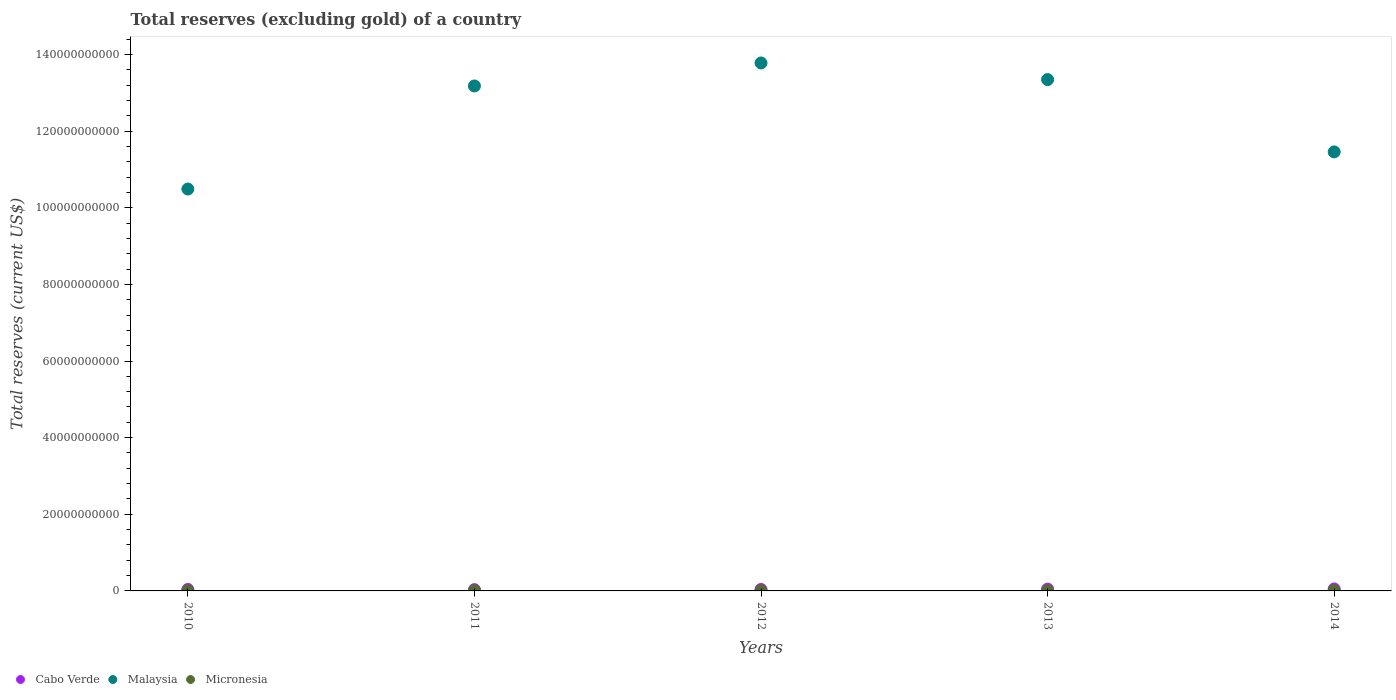How many different coloured dotlines are there?
Your answer should be very brief. 3. Is the number of dotlines equal to the number of legend labels?
Offer a terse response. Yes. What is the total reserves (excluding gold) in Cabo Verde in 2014?
Give a very brief answer. 5.11e+08. Across all years, what is the maximum total reserves (excluding gold) in Cabo Verde?
Ensure brevity in your answer.  5.11e+08. Across all years, what is the minimum total reserves (excluding gold) in Cabo Verde?
Provide a succinct answer. 3.39e+08. In which year was the total reserves (excluding gold) in Cabo Verde maximum?
Keep it short and to the point. 2014. In which year was the total reserves (excluding gold) in Cabo Verde minimum?
Offer a very short reply. 2011. What is the total total reserves (excluding gold) in Micronesia in the graph?
Give a very brief answer. 4.06e+08. What is the difference between the total reserves (excluding gold) in Malaysia in 2010 and that in 2014?
Give a very brief answer. -9.69e+09. What is the difference between the total reserves (excluding gold) in Micronesia in 2011 and the total reserves (excluding gold) in Cabo Verde in 2010?
Keep it short and to the point. -3.07e+08. What is the average total reserves (excluding gold) in Micronesia per year?
Keep it short and to the point. 8.12e+07. In the year 2010, what is the difference between the total reserves (excluding gold) in Micronesia and total reserves (excluding gold) in Malaysia?
Make the answer very short. -1.05e+11. In how many years, is the total reserves (excluding gold) in Cabo Verde greater than 104000000000 US$?
Offer a terse response. 0. What is the ratio of the total reserves (excluding gold) in Cabo Verde in 2011 to that in 2012?
Ensure brevity in your answer.  0.9. Is the total reserves (excluding gold) in Malaysia in 2011 less than that in 2012?
Keep it short and to the point. Yes. Is the difference between the total reserves (excluding gold) in Micronesia in 2012 and 2013 greater than the difference between the total reserves (excluding gold) in Malaysia in 2012 and 2013?
Keep it short and to the point. No. What is the difference between the highest and the second highest total reserves (excluding gold) in Cabo Verde?
Your answer should be compact. 3.56e+07. What is the difference between the highest and the lowest total reserves (excluding gold) in Cabo Verde?
Offer a very short reply. 1.72e+08. Is the sum of the total reserves (excluding gold) in Cabo Verde in 2010 and 2012 greater than the maximum total reserves (excluding gold) in Micronesia across all years?
Offer a very short reply. Yes. Does the total reserves (excluding gold) in Micronesia monotonically increase over the years?
Ensure brevity in your answer.  Yes. Is the total reserves (excluding gold) in Malaysia strictly greater than the total reserves (excluding gold) in Cabo Verde over the years?
Provide a succinct answer. Yes. Is the total reserves (excluding gold) in Cabo Verde strictly less than the total reserves (excluding gold) in Micronesia over the years?
Provide a succinct answer. No. How many dotlines are there?
Offer a terse response. 3. What is the difference between two consecutive major ticks on the Y-axis?
Offer a terse response. 2.00e+1. Are the values on the major ticks of Y-axis written in scientific E-notation?
Your response must be concise. No. Does the graph contain any zero values?
Make the answer very short. No. Where does the legend appear in the graph?
Your response must be concise. Bottom left. How are the legend labels stacked?
Give a very brief answer. Horizontal. What is the title of the graph?
Give a very brief answer. Total reserves (excluding gold) of a country. What is the label or title of the Y-axis?
Provide a succinct answer. Total reserves (current US$). What is the Total reserves (current US$) in Cabo Verde in 2010?
Give a very brief answer. 3.82e+08. What is the Total reserves (current US$) of Malaysia in 2010?
Ensure brevity in your answer.  1.05e+11. What is the Total reserves (current US$) of Micronesia in 2010?
Offer a very short reply. 5.58e+07. What is the Total reserves (current US$) in Cabo Verde in 2011?
Your answer should be very brief. 3.39e+08. What is the Total reserves (current US$) in Malaysia in 2011?
Your answer should be very brief. 1.32e+11. What is the Total reserves (current US$) in Micronesia in 2011?
Provide a succinct answer. 7.51e+07. What is the Total reserves (current US$) of Cabo Verde in 2012?
Offer a very short reply. 3.76e+08. What is the Total reserves (current US$) of Malaysia in 2012?
Provide a short and direct response. 1.38e+11. What is the Total reserves (current US$) of Micronesia in 2012?
Ensure brevity in your answer.  7.68e+07. What is the Total reserves (current US$) of Cabo Verde in 2013?
Keep it short and to the point. 4.75e+08. What is the Total reserves (current US$) in Malaysia in 2013?
Offer a terse response. 1.33e+11. What is the Total reserves (current US$) in Micronesia in 2013?
Your answer should be compact. 8.43e+07. What is the Total reserves (current US$) in Cabo Verde in 2014?
Your answer should be very brief. 5.11e+08. What is the Total reserves (current US$) in Malaysia in 2014?
Give a very brief answer. 1.15e+11. What is the Total reserves (current US$) in Micronesia in 2014?
Your answer should be very brief. 1.14e+08. Across all years, what is the maximum Total reserves (current US$) in Cabo Verde?
Ensure brevity in your answer.  5.11e+08. Across all years, what is the maximum Total reserves (current US$) in Malaysia?
Offer a terse response. 1.38e+11. Across all years, what is the maximum Total reserves (current US$) of Micronesia?
Offer a very short reply. 1.14e+08. Across all years, what is the minimum Total reserves (current US$) of Cabo Verde?
Offer a terse response. 3.39e+08. Across all years, what is the minimum Total reserves (current US$) of Malaysia?
Offer a very short reply. 1.05e+11. Across all years, what is the minimum Total reserves (current US$) of Micronesia?
Your response must be concise. 5.58e+07. What is the total Total reserves (current US$) in Cabo Verde in the graph?
Offer a terse response. 2.08e+09. What is the total Total reserves (current US$) of Malaysia in the graph?
Offer a terse response. 6.22e+11. What is the total Total reserves (current US$) in Micronesia in the graph?
Your answer should be very brief. 4.06e+08. What is the difference between the Total reserves (current US$) in Cabo Verde in 2010 and that in 2011?
Your response must be concise. 4.36e+07. What is the difference between the Total reserves (current US$) of Malaysia in 2010 and that in 2011?
Keep it short and to the point. -2.69e+1. What is the difference between the Total reserves (current US$) of Micronesia in 2010 and that in 2011?
Provide a succinct answer. -1.93e+07. What is the difference between the Total reserves (current US$) in Cabo Verde in 2010 and that in 2012?
Offer a terse response. 6.35e+06. What is the difference between the Total reserves (current US$) in Malaysia in 2010 and that in 2012?
Make the answer very short. -3.29e+1. What is the difference between the Total reserves (current US$) in Micronesia in 2010 and that in 2012?
Your answer should be compact. -2.10e+07. What is the difference between the Total reserves (current US$) of Cabo Verde in 2010 and that in 2013?
Provide a succinct answer. -9.31e+07. What is the difference between the Total reserves (current US$) of Malaysia in 2010 and that in 2013?
Your answer should be compact. -2.86e+1. What is the difference between the Total reserves (current US$) in Micronesia in 2010 and that in 2013?
Give a very brief answer. -2.86e+07. What is the difference between the Total reserves (current US$) in Cabo Verde in 2010 and that in 2014?
Ensure brevity in your answer.  -1.29e+08. What is the difference between the Total reserves (current US$) of Malaysia in 2010 and that in 2014?
Give a very brief answer. -9.69e+09. What is the difference between the Total reserves (current US$) of Micronesia in 2010 and that in 2014?
Give a very brief answer. -5.84e+07. What is the difference between the Total reserves (current US$) of Cabo Verde in 2011 and that in 2012?
Offer a terse response. -3.72e+07. What is the difference between the Total reserves (current US$) of Malaysia in 2011 and that in 2012?
Make the answer very short. -6.00e+09. What is the difference between the Total reserves (current US$) in Micronesia in 2011 and that in 2012?
Offer a terse response. -1.73e+06. What is the difference between the Total reserves (current US$) in Cabo Verde in 2011 and that in 2013?
Provide a short and direct response. -1.37e+08. What is the difference between the Total reserves (current US$) of Malaysia in 2011 and that in 2013?
Give a very brief answer. -1.66e+09. What is the difference between the Total reserves (current US$) in Micronesia in 2011 and that in 2013?
Keep it short and to the point. -9.28e+06. What is the difference between the Total reserves (current US$) of Cabo Verde in 2011 and that in 2014?
Your answer should be very brief. -1.72e+08. What is the difference between the Total reserves (current US$) of Malaysia in 2011 and that in 2014?
Ensure brevity in your answer.  1.72e+1. What is the difference between the Total reserves (current US$) of Micronesia in 2011 and that in 2014?
Provide a succinct answer. -3.91e+07. What is the difference between the Total reserves (current US$) of Cabo Verde in 2012 and that in 2013?
Offer a terse response. -9.95e+07. What is the difference between the Total reserves (current US$) of Malaysia in 2012 and that in 2013?
Offer a very short reply. 4.34e+09. What is the difference between the Total reserves (current US$) of Micronesia in 2012 and that in 2013?
Your answer should be very brief. -7.55e+06. What is the difference between the Total reserves (current US$) of Cabo Verde in 2012 and that in 2014?
Ensure brevity in your answer.  -1.35e+08. What is the difference between the Total reserves (current US$) in Malaysia in 2012 and that in 2014?
Your answer should be very brief. 2.32e+1. What is the difference between the Total reserves (current US$) of Micronesia in 2012 and that in 2014?
Offer a very short reply. -3.73e+07. What is the difference between the Total reserves (current US$) of Cabo Verde in 2013 and that in 2014?
Provide a short and direct response. -3.56e+07. What is the difference between the Total reserves (current US$) of Malaysia in 2013 and that in 2014?
Your response must be concise. 1.89e+1. What is the difference between the Total reserves (current US$) in Micronesia in 2013 and that in 2014?
Offer a terse response. -2.98e+07. What is the difference between the Total reserves (current US$) of Cabo Verde in 2010 and the Total reserves (current US$) of Malaysia in 2011?
Your answer should be compact. -1.31e+11. What is the difference between the Total reserves (current US$) in Cabo Verde in 2010 and the Total reserves (current US$) in Micronesia in 2011?
Offer a very short reply. 3.07e+08. What is the difference between the Total reserves (current US$) in Malaysia in 2010 and the Total reserves (current US$) in Micronesia in 2011?
Make the answer very short. 1.05e+11. What is the difference between the Total reserves (current US$) of Cabo Verde in 2010 and the Total reserves (current US$) of Malaysia in 2012?
Keep it short and to the point. -1.37e+11. What is the difference between the Total reserves (current US$) in Cabo Verde in 2010 and the Total reserves (current US$) in Micronesia in 2012?
Keep it short and to the point. 3.05e+08. What is the difference between the Total reserves (current US$) of Malaysia in 2010 and the Total reserves (current US$) of Micronesia in 2012?
Your response must be concise. 1.05e+11. What is the difference between the Total reserves (current US$) of Cabo Verde in 2010 and the Total reserves (current US$) of Malaysia in 2013?
Provide a short and direct response. -1.33e+11. What is the difference between the Total reserves (current US$) in Cabo Verde in 2010 and the Total reserves (current US$) in Micronesia in 2013?
Offer a terse response. 2.98e+08. What is the difference between the Total reserves (current US$) in Malaysia in 2010 and the Total reserves (current US$) in Micronesia in 2013?
Provide a short and direct response. 1.05e+11. What is the difference between the Total reserves (current US$) in Cabo Verde in 2010 and the Total reserves (current US$) in Malaysia in 2014?
Offer a terse response. -1.14e+11. What is the difference between the Total reserves (current US$) of Cabo Verde in 2010 and the Total reserves (current US$) of Micronesia in 2014?
Provide a succinct answer. 2.68e+08. What is the difference between the Total reserves (current US$) of Malaysia in 2010 and the Total reserves (current US$) of Micronesia in 2014?
Make the answer very short. 1.05e+11. What is the difference between the Total reserves (current US$) in Cabo Verde in 2011 and the Total reserves (current US$) in Malaysia in 2012?
Your response must be concise. -1.37e+11. What is the difference between the Total reserves (current US$) of Cabo Verde in 2011 and the Total reserves (current US$) of Micronesia in 2012?
Provide a short and direct response. 2.62e+08. What is the difference between the Total reserves (current US$) of Malaysia in 2011 and the Total reserves (current US$) of Micronesia in 2012?
Make the answer very short. 1.32e+11. What is the difference between the Total reserves (current US$) of Cabo Verde in 2011 and the Total reserves (current US$) of Malaysia in 2013?
Make the answer very short. -1.33e+11. What is the difference between the Total reserves (current US$) of Cabo Verde in 2011 and the Total reserves (current US$) of Micronesia in 2013?
Provide a succinct answer. 2.54e+08. What is the difference between the Total reserves (current US$) in Malaysia in 2011 and the Total reserves (current US$) in Micronesia in 2013?
Provide a succinct answer. 1.32e+11. What is the difference between the Total reserves (current US$) in Cabo Verde in 2011 and the Total reserves (current US$) in Malaysia in 2014?
Give a very brief answer. -1.14e+11. What is the difference between the Total reserves (current US$) in Cabo Verde in 2011 and the Total reserves (current US$) in Micronesia in 2014?
Your answer should be very brief. 2.24e+08. What is the difference between the Total reserves (current US$) of Malaysia in 2011 and the Total reserves (current US$) of Micronesia in 2014?
Keep it short and to the point. 1.32e+11. What is the difference between the Total reserves (current US$) in Cabo Verde in 2012 and the Total reserves (current US$) in Malaysia in 2013?
Provide a short and direct response. -1.33e+11. What is the difference between the Total reserves (current US$) in Cabo Verde in 2012 and the Total reserves (current US$) in Micronesia in 2013?
Your answer should be very brief. 2.91e+08. What is the difference between the Total reserves (current US$) in Malaysia in 2012 and the Total reserves (current US$) in Micronesia in 2013?
Your response must be concise. 1.38e+11. What is the difference between the Total reserves (current US$) of Cabo Verde in 2012 and the Total reserves (current US$) of Malaysia in 2014?
Offer a very short reply. -1.14e+11. What is the difference between the Total reserves (current US$) of Cabo Verde in 2012 and the Total reserves (current US$) of Micronesia in 2014?
Ensure brevity in your answer.  2.62e+08. What is the difference between the Total reserves (current US$) of Malaysia in 2012 and the Total reserves (current US$) of Micronesia in 2014?
Keep it short and to the point. 1.38e+11. What is the difference between the Total reserves (current US$) of Cabo Verde in 2013 and the Total reserves (current US$) of Malaysia in 2014?
Your answer should be very brief. -1.14e+11. What is the difference between the Total reserves (current US$) of Cabo Verde in 2013 and the Total reserves (current US$) of Micronesia in 2014?
Ensure brevity in your answer.  3.61e+08. What is the difference between the Total reserves (current US$) in Malaysia in 2013 and the Total reserves (current US$) in Micronesia in 2014?
Make the answer very short. 1.33e+11. What is the average Total reserves (current US$) in Cabo Verde per year?
Offer a terse response. 4.17e+08. What is the average Total reserves (current US$) in Malaysia per year?
Make the answer very short. 1.24e+11. What is the average Total reserves (current US$) of Micronesia per year?
Make the answer very short. 8.12e+07. In the year 2010, what is the difference between the Total reserves (current US$) in Cabo Verde and Total reserves (current US$) in Malaysia?
Offer a very short reply. -1.05e+11. In the year 2010, what is the difference between the Total reserves (current US$) in Cabo Verde and Total reserves (current US$) in Micronesia?
Your answer should be compact. 3.26e+08. In the year 2010, what is the difference between the Total reserves (current US$) of Malaysia and Total reserves (current US$) of Micronesia?
Your response must be concise. 1.05e+11. In the year 2011, what is the difference between the Total reserves (current US$) in Cabo Verde and Total reserves (current US$) in Malaysia?
Give a very brief answer. -1.31e+11. In the year 2011, what is the difference between the Total reserves (current US$) of Cabo Verde and Total reserves (current US$) of Micronesia?
Your answer should be compact. 2.64e+08. In the year 2011, what is the difference between the Total reserves (current US$) in Malaysia and Total reserves (current US$) in Micronesia?
Your response must be concise. 1.32e+11. In the year 2012, what is the difference between the Total reserves (current US$) of Cabo Verde and Total reserves (current US$) of Malaysia?
Make the answer very short. -1.37e+11. In the year 2012, what is the difference between the Total reserves (current US$) in Cabo Verde and Total reserves (current US$) in Micronesia?
Give a very brief answer. 2.99e+08. In the year 2012, what is the difference between the Total reserves (current US$) of Malaysia and Total reserves (current US$) of Micronesia?
Provide a succinct answer. 1.38e+11. In the year 2013, what is the difference between the Total reserves (current US$) in Cabo Verde and Total reserves (current US$) in Malaysia?
Offer a very short reply. -1.33e+11. In the year 2013, what is the difference between the Total reserves (current US$) in Cabo Verde and Total reserves (current US$) in Micronesia?
Your answer should be compact. 3.91e+08. In the year 2013, what is the difference between the Total reserves (current US$) in Malaysia and Total reserves (current US$) in Micronesia?
Your response must be concise. 1.33e+11. In the year 2014, what is the difference between the Total reserves (current US$) in Cabo Verde and Total reserves (current US$) in Malaysia?
Provide a short and direct response. -1.14e+11. In the year 2014, what is the difference between the Total reserves (current US$) of Cabo Verde and Total reserves (current US$) of Micronesia?
Offer a terse response. 3.97e+08. In the year 2014, what is the difference between the Total reserves (current US$) of Malaysia and Total reserves (current US$) of Micronesia?
Your answer should be compact. 1.14e+11. What is the ratio of the Total reserves (current US$) of Cabo Verde in 2010 to that in 2011?
Give a very brief answer. 1.13. What is the ratio of the Total reserves (current US$) of Malaysia in 2010 to that in 2011?
Ensure brevity in your answer.  0.8. What is the ratio of the Total reserves (current US$) of Micronesia in 2010 to that in 2011?
Keep it short and to the point. 0.74. What is the ratio of the Total reserves (current US$) in Cabo Verde in 2010 to that in 2012?
Offer a very short reply. 1.02. What is the ratio of the Total reserves (current US$) of Malaysia in 2010 to that in 2012?
Offer a very short reply. 0.76. What is the ratio of the Total reserves (current US$) of Micronesia in 2010 to that in 2012?
Your answer should be very brief. 0.73. What is the ratio of the Total reserves (current US$) of Cabo Verde in 2010 to that in 2013?
Your answer should be compact. 0.8. What is the ratio of the Total reserves (current US$) of Malaysia in 2010 to that in 2013?
Keep it short and to the point. 0.79. What is the ratio of the Total reserves (current US$) of Micronesia in 2010 to that in 2013?
Your response must be concise. 0.66. What is the ratio of the Total reserves (current US$) of Cabo Verde in 2010 to that in 2014?
Your answer should be very brief. 0.75. What is the ratio of the Total reserves (current US$) in Malaysia in 2010 to that in 2014?
Provide a short and direct response. 0.92. What is the ratio of the Total reserves (current US$) of Micronesia in 2010 to that in 2014?
Provide a short and direct response. 0.49. What is the ratio of the Total reserves (current US$) in Cabo Verde in 2011 to that in 2012?
Keep it short and to the point. 0.9. What is the ratio of the Total reserves (current US$) of Malaysia in 2011 to that in 2012?
Your response must be concise. 0.96. What is the ratio of the Total reserves (current US$) in Micronesia in 2011 to that in 2012?
Give a very brief answer. 0.98. What is the ratio of the Total reserves (current US$) of Cabo Verde in 2011 to that in 2013?
Provide a succinct answer. 0.71. What is the ratio of the Total reserves (current US$) of Malaysia in 2011 to that in 2013?
Offer a very short reply. 0.99. What is the ratio of the Total reserves (current US$) in Micronesia in 2011 to that in 2013?
Give a very brief answer. 0.89. What is the ratio of the Total reserves (current US$) in Cabo Verde in 2011 to that in 2014?
Ensure brevity in your answer.  0.66. What is the ratio of the Total reserves (current US$) of Malaysia in 2011 to that in 2014?
Provide a short and direct response. 1.15. What is the ratio of the Total reserves (current US$) of Micronesia in 2011 to that in 2014?
Ensure brevity in your answer.  0.66. What is the ratio of the Total reserves (current US$) of Cabo Verde in 2012 to that in 2013?
Provide a succinct answer. 0.79. What is the ratio of the Total reserves (current US$) of Malaysia in 2012 to that in 2013?
Offer a very short reply. 1.03. What is the ratio of the Total reserves (current US$) of Micronesia in 2012 to that in 2013?
Offer a very short reply. 0.91. What is the ratio of the Total reserves (current US$) in Cabo Verde in 2012 to that in 2014?
Your answer should be very brief. 0.74. What is the ratio of the Total reserves (current US$) of Malaysia in 2012 to that in 2014?
Provide a succinct answer. 1.2. What is the ratio of the Total reserves (current US$) in Micronesia in 2012 to that in 2014?
Your answer should be compact. 0.67. What is the ratio of the Total reserves (current US$) of Cabo Verde in 2013 to that in 2014?
Your response must be concise. 0.93. What is the ratio of the Total reserves (current US$) in Malaysia in 2013 to that in 2014?
Offer a terse response. 1.16. What is the ratio of the Total reserves (current US$) in Micronesia in 2013 to that in 2014?
Offer a very short reply. 0.74. What is the difference between the highest and the second highest Total reserves (current US$) of Cabo Verde?
Your response must be concise. 3.56e+07. What is the difference between the highest and the second highest Total reserves (current US$) of Malaysia?
Your response must be concise. 4.34e+09. What is the difference between the highest and the second highest Total reserves (current US$) of Micronesia?
Your answer should be very brief. 2.98e+07. What is the difference between the highest and the lowest Total reserves (current US$) in Cabo Verde?
Offer a terse response. 1.72e+08. What is the difference between the highest and the lowest Total reserves (current US$) of Malaysia?
Your response must be concise. 3.29e+1. What is the difference between the highest and the lowest Total reserves (current US$) in Micronesia?
Ensure brevity in your answer.  5.84e+07. 